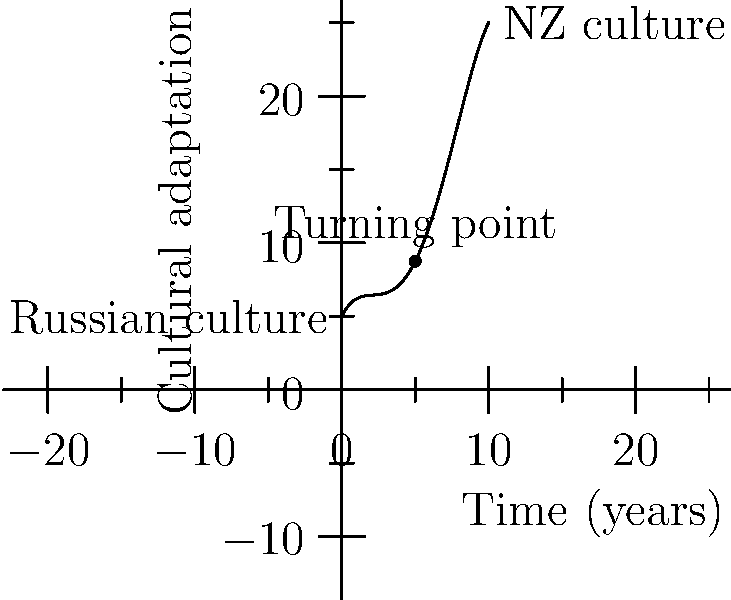The graph represents a cultural adaptation curve for a Russian-born individual adopted into a New Zealand family. The x-axis represents time in years since adoption, and the y-axis represents the level of cultural adaptation. At which point (in years) does the rate of cultural adaptation start to slow down? To find the point where the rate of cultural adaptation starts to slow down, we need to identify the turning point of the polynomial function. This is where the curve changes from concave up to concave down.

Steps to find the turning point:
1. The polynomial function is of degree 4, so it will have at most 3 turning points.
2. From the graph, we can see there is only one visible turning point.
3. This turning point occurs at the maximum of the curve.
4. The x-coordinate of the turning point represents the time in years when the rate of adaptation starts to slow down.
5. By examining the graph, we can see that the turning point occurs at x = 5 years.

At this point (5 years), the individual has reached their peak rate of cultural adaptation. After this point, while they continue to adapt, the rate of adaptation slows down as they become more integrated into New Zealand culture while maintaining aspects of their Russian heritage.
Answer: 5 years 